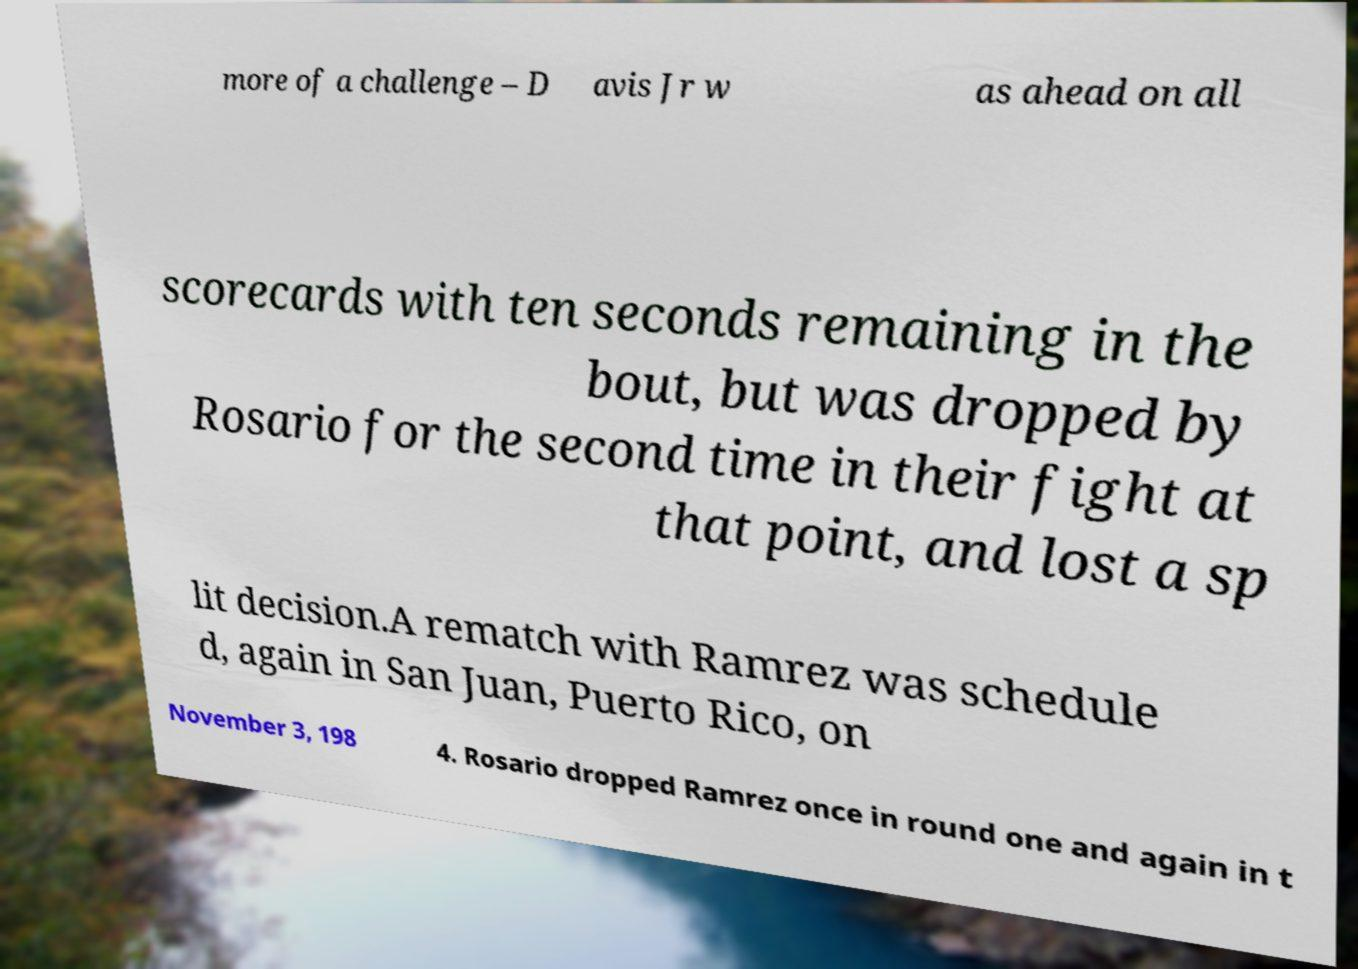Please identify and transcribe the text found in this image. more of a challenge – D avis Jr w as ahead on all scorecards with ten seconds remaining in the bout, but was dropped by Rosario for the second time in their fight at that point, and lost a sp lit decision.A rematch with Ramrez was schedule d, again in San Juan, Puerto Rico, on November 3, 198 4. Rosario dropped Ramrez once in round one and again in t 